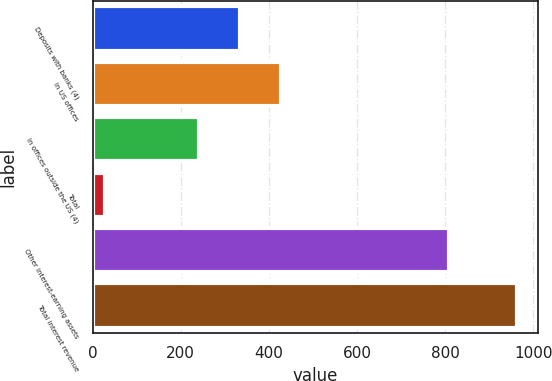Convert chart. <chart><loc_0><loc_0><loc_500><loc_500><bar_chart><fcel>Deposits with banks (4)<fcel>In US offices<fcel>In offices outside the US (4)<fcel>Total<fcel>Other interest-earning assets<fcel>Total interest revenue<nl><fcel>334.6<fcel>428.2<fcel>241<fcel>27<fcel>810<fcel>963<nl></chart> 